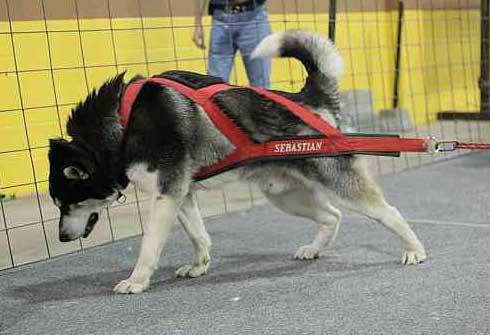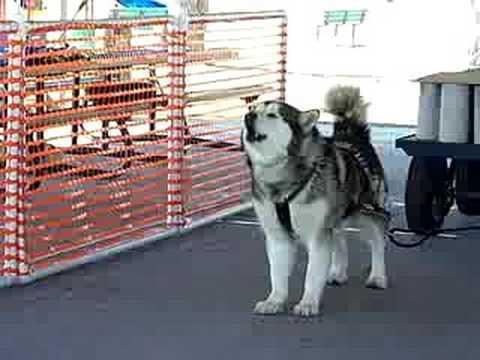The first image is the image on the left, the second image is the image on the right. For the images displayed, is the sentence "A dog is pulling a cart using only its hind legs in one of the pictures." factually correct? Answer yes or no. No. The first image is the image on the left, the second image is the image on the right. Given the left and right images, does the statement "One image shows a leftward-turned dog in a harness leaning forward in profile as it strains to pull something that is out of sight, and the other image shows a dog standing on all fours with its head raised and mouth open." hold true? Answer yes or no. Yes. 